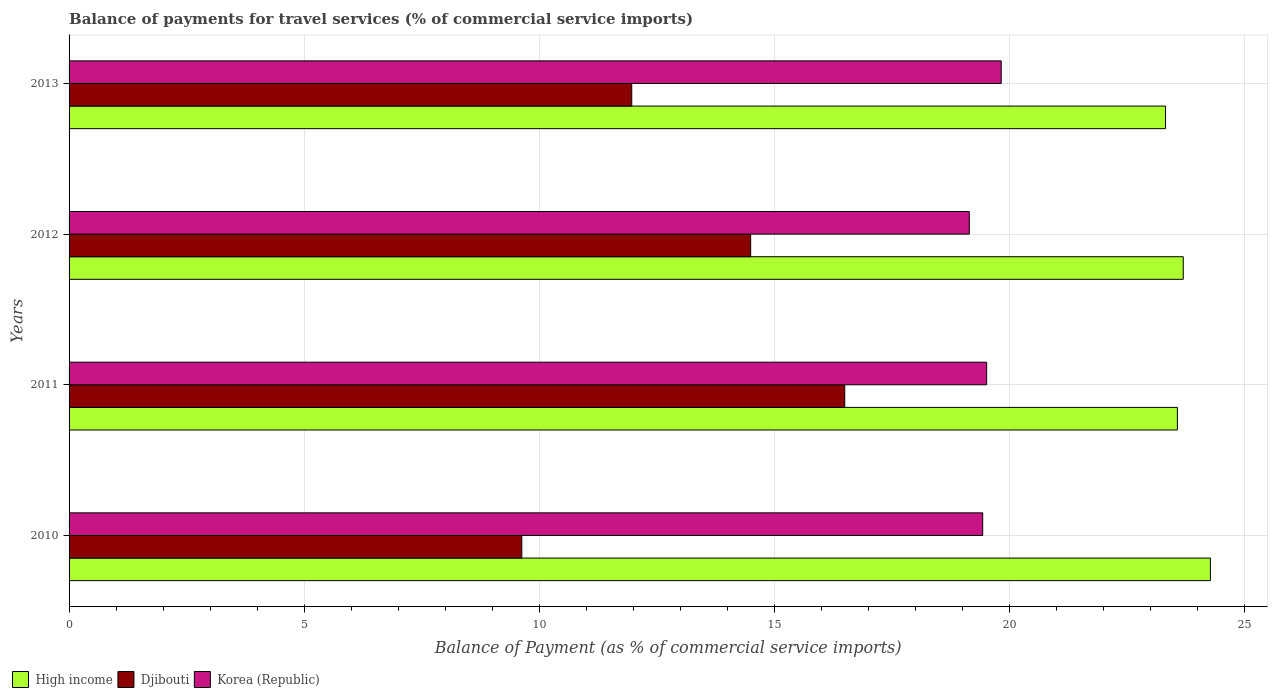How many different coloured bars are there?
Provide a short and direct response. 3. How many bars are there on the 3rd tick from the top?
Provide a succinct answer. 3. What is the label of the 2nd group of bars from the top?
Offer a very short reply. 2012. In how many cases, is the number of bars for a given year not equal to the number of legend labels?
Offer a very short reply. 0. What is the balance of payments for travel services in Djibouti in 2010?
Ensure brevity in your answer.  9.63. Across all years, what is the maximum balance of payments for travel services in Djibouti?
Offer a terse response. 16.5. Across all years, what is the minimum balance of payments for travel services in Djibouti?
Provide a succinct answer. 9.63. In which year was the balance of payments for travel services in Djibouti maximum?
Give a very brief answer. 2011. What is the total balance of payments for travel services in Djibouti in the graph?
Your response must be concise. 52.61. What is the difference between the balance of payments for travel services in Djibouti in 2010 and that in 2012?
Your answer should be very brief. -4.87. What is the difference between the balance of payments for travel services in Djibouti in 2011 and the balance of payments for travel services in High income in 2012?
Give a very brief answer. -7.2. What is the average balance of payments for travel services in Djibouti per year?
Ensure brevity in your answer.  13.15. In the year 2011, what is the difference between the balance of payments for travel services in Djibouti and balance of payments for travel services in High income?
Make the answer very short. -7.08. In how many years, is the balance of payments for travel services in Djibouti greater than 3 %?
Ensure brevity in your answer.  4. What is the ratio of the balance of payments for travel services in Djibouti in 2010 to that in 2011?
Offer a very short reply. 0.58. What is the difference between the highest and the second highest balance of payments for travel services in High income?
Your answer should be compact. 0.58. What is the difference between the highest and the lowest balance of payments for travel services in High income?
Your response must be concise. 0.95. In how many years, is the balance of payments for travel services in High income greater than the average balance of payments for travel services in High income taken over all years?
Offer a very short reply. 1. What does the 3rd bar from the bottom in 2013 represents?
Provide a short and direct response. Korea (Republic). How many bars are there?
Your response must be concise. 12. Are the values on the major ticks of X-axis written in scientific E-notation?
Your answer should be very brief. No. Does the graph contain grids?
Your answer should be very brief. Yes. Where does the legend appear in the graph?
Offer a very short reply. Bottom left. How many legend labels are there?
Offer a terse response. 3. How are the legend labels stacked?
Provide a succinct answer. Horizontal. What is the title of the graph?
Your answer should be compact. Balance of payments for travel services (% of commercial service imports). Does "Sao Tome and Principe" appear as one of the legend labels in the graph?
Give a very brief answer. No. What is the label or title of the X-axis?
Offer a very short reply. Balance of Payment (as % of commercial service imports). What is the label or title of the Y-axis?
Keep it short and to the point. Years. What is the Balance of Payment (as % of commercial service imports) in High income in 2010?
Your response must be concise. 24.28. What is the Balance of Payment (as % of commercial service imports) of Djibouti in 2010?
Give a very brief answer. 9.63. What is the Balance of Payment (as % of commercial service imports) in Korea (Republic) in 2010?
Provide a succinct answer. 19.44. What is the Balance of Payment (as % of commercial service imports) of High income in 2011?
Your answer should be compact. 23.58. What is the Balance of Payment (as % of commercial service imports) in Djibouti in 2011?
Offer a very short reply. 16.5. What is the Balance of Payment (as % of commercial service imports) in Korea (Republic) in 2011?
Keep it short and to the point. 19.52. What is the Balance of Payment (as % of commercial service imports) of High income in 2012?
Offer a terse response. 23.7. What is the Balance of Payment (as % of commercial service imports) of Djibouti in 2012?
Your answer should be compact. 14.5. What is the Balance of Payment (as % of commercial service imports) of Korea (Republic) in 2012?
Provide a short and direct response. 19.15. What is the Balance of Payment (as % of commercial service imports) in High income in 2013?
Keep it short and to the point. 23.33. What is the Balance of Payment (as % of commercial service imports) in Djibouti in 2013?
Ensure brevity in your answer.  11.97. What is the Balance of Payment (as % of commercial service imports) in Korea (Republic) in 2013?
Ensure brevity in your answer.  19.83. Across all years, what is the maximum Balance of Payment (as % of commercial service imports) of High income?
Make the answer very short. 24.28. Across all years, what is the maximum Balance of Payment (as % of commercial service imports) in Djibouti?
Give a very brief answer. 16.5. Across all years, what is the maximum Balance of Payment (as % of commercial service imports) in Korea (Republic)?
Make the answer very short. 19.83. Across all years, what is the minimum Balance of Payment (as % of commercial service imports) in High income?
Your response must be concise. 23.33. Across all years, what is the minimum Balance of Payment (as % of commercial service imports) in Djibouti?
Your answer should be very brief. 9.63. Across all years, what is the minimum Balance of Payment (as % of commercial service imports) of Korea (Republic)?
Provide a short and direct response. 19.15. What is the total Balance of Payment (as % of commercial service imports) of High income in the graph?
Provide a succinct answer. 94.89. What is the total Balance of Payment (as % of commercial service imports) of Djibouti in the graph?
Make the answer very short. 52.61. What is the total Balance of Payment (as % of commercial service imports) of Korea (Republic) in the graph?
Keep it short and to the point. 77.94. What is the difference between the Balance of Payment (as % of commercial service imports) in High income in 2010 and that in 2011?
Give a very brief answer. 0.7. What is the difference between the Balance of Payment (as % of commercial service imports) of Djibouti in 2010 and that in 2011?
Provide a short and direct response. -6.87. What is the difference between the Balance of Payment (as % of commercial service imports) of Korea (Republic) in 2010 and that in 2011?
Keep it short and to the point. -0.08. What is the difference between the Balance of Payment (as % of commercial service imports) of High income in 2010 and that in 2012?
Your answer should be compact. 0.58. What is the difference between the Balance of Payment (as % of commercial service imports) of Djibouti in 2010 and that in 2012?
Provide a short and direct response. -4.87. What is the difference between the Balance of Payment (as % of commercial service imports) of Korea (Republic) in 2010 and that in 2012?
Provide a short and direct response. 0.28. What is the difference between the Balance of Payment (as % of commercial service imports) of High income in 2010 and that in 2013?
Your response must be concise. 0.95. What is the difference between the Balance of Payment (as % of commercial service imports) in Djibouti in 2010 and that in 2013?
Keep it short and to the point. -2.34. What is the difference between the Balance of Payment (as % of commercial service imports) in Korea (Republic) in 2010 and that in 2013?
Offer a very short reply. -0.39. What is the difference between the Balance of Payment (as % of commercial service imports) of High income in 2011 and that in 2012?
Your answer should be very brief. -0.13. What is the difference between the Balance of Payment (as % of commercial service imports) in Djibouti in 2011 and that in 2012?
Provide a succinct answer. 2. What is the difference between the Balance of Payment (as % of commercial service imports) in Korea (Republic) in 2011 and that in 2012?
Keep it short and to the point. 0.37. What is the difference between the Balance of Payment (as % of commercial service imports) in High income in 2011 and that in 2013?
Your response must be concise. 0.25. What is the difference between the Balance of Payment (as % of commercial service imports) of Djibouti in 2011 and that in 2013?
Make the answer very short. 4.53. What is the difference between the Balance of Payment (as % of commercial service imports) of Korea (Republic) in 2011 and that in 2013?
Give a very brief answer. -0.31. What is the difference between the Balance of Payment (as % of commercial service imports) of High income in 2012 and that in 2013?
Provide a succinct answer. 0.38. What is the difference between the Balance of Payment (as % of commercial service imports) of Djibouti in 2012 and that in 2013?
Provide a short and direct response. 2.53. What is the difference between the Balance of Payment (as % of commercial service imports) of Korea (Republic) in 2012 and that in 2013?
Your response must be concise. -0.68. What is the difference between the Balance of Payment (as % of commercial service imports) in High income in 2010 and the Balance of Payment (as % of commercial service imports) in Djibouti in 2011?
Give a very brief answer. 7.78. What is the difference between the Balance of Payment (as % of commercial service imports) in High income in 2010 and the Balance of Payment (as % of commercial service imports) in Korea (Republic) in 2011?
Provide a succinct answer. 4.76. What is the difference between the Balance of Payment (as % of commercial service imports) in Djibouti in 2010 and the Balance of Payment (as % of commercial service imports) in Korea (Republic) in 2011?
Make the answer very short. -9.89. What is the difference between the Balance of Payment (as % of commercial service imports) in High income in 2010 and the Balance of Payment (as % of commercial service imports) in Djibouti in 2012?
Make the answer very short. 9.78. What is the difference between the Balance of Payment (as % of commercial service imports) in High income in 2010 and the Balance of Payment (as % of commercial service imports) in Korea (Republic) in 2012?
Make the answer very short. 5.13. What is the difference between the Balance of Payment (as % of commercial service imports) of Djibouti in 2010 and the Balance of Payment (as % of commercial service imports) of Korea (Republic) in 2012?
Your response must be concise. -9.52. What is the difference between the Balance of Payment (as % of commercial service imports) in High income in 2010 and the Balance of Payment (as % of commercial service imports) in Djibouti in 2013?
Your response must be concise. 12.31. What is the difference between the Balance of Payment (as % of commercial service imports) in High income in 2010 and the Balance of Payment (as % of commercial service imports) in Korea (Republic) in 2013?
Keep it short and to the point. 4.45. What is the difference between the Balance of Payment (as % of commercial service imports) in Djibouti in 2010 and the Balance of Payment (as % of commercial service imports) in Korea (Republic) in 2013?
Keep it short and to the point. -10.2. What is the difference between the Balance of Payment (as % of commercial service imports) in High income in 2011 and the Balance of Payment (as % of commercial service imports) in Djibouti in 2012?
Offer a terse response. 9.08. What is the difference between the Balance of Payment (as % of commercial service imports) of High income in 2011 and the Balance of Payment (as % of commercial service imports) of Korea (Republic) in 2012?
Provide a succinct answer. 4.43. What is the difference between the Balance of Payment (as % of commercial service imports) in Djibouti in 2011 and the Balance of Payment (as % of commercial service imports) in Korea (Republic) in 2012?
Your answer should be compact. -2.65. What is the difference between the Balance of Payment (as % of commercial service imports) in High income in 2011 and the Balance of Payment (as % of commercial service imports) in Djibouti in 2013?
Make the answer very short. 11.61. What is the difference between the Balance of Payment (as % of commercial service imports) in High income in 2011 and the Balance of Payment (as % of commercial service imports) in Korea (Republic) in 2013?
Offer a terse response. 3.75. What is the difference between the Balance of Payment (as % of commercial service imports) in Djibouti in 2011 and the Balance of Payment (as % of commercial service imports) in Korea (Republic) in 2013?
Your response must be concise. -3.33. What is the difference between the Balance of Payment (as % of commercial service imports) of High income in 2012 and the Balance of Payment (as % of commercial service imports) of Djibouti in 2013?
Make the answer very short. 11.73. What is the difference between the Balance of Payment (as % of commercial service imports) in High income in 2012 and the Balance of Payment (as % of commercial service imports) in Korea (Republic) in 2013?
Provide a short and direct response. 3.87. What is the difference between the Balance of Payment (as % of commercial service imports) in Djibouti in 2012 and the Balance of Payment (as % of commercial service imports) in Korea (Republic) in 2013?
Keep it short and to the point. -5.33. What is the average Balance of Payment (as % of commercial service imports) of High income per year?
Give a very brief answer. 23.72. What is the average Balance of Payment (as % of commercial service imports) of Djibouti per year?
Provide a succinct answer. 13.15. What is the average Balance of Payment (as % of commercial service imports) in Korea (Republic) per year?
Give a very brief answer. 19.49. In the year 2010, what is the difference between the Balance of Payment (as % of commercial service imports) in High income and Balance of Payment (as % of commercial service imports) in Djibouti?
Offer a terse response. 14.65. In the year 2010, what is the difference between the Balance of Payment (as % of commercial service imports) of High income and Balance of Payment (as % of commercial service imports) of Korea (Republic)?
Provide a short and direct response. 4.85. In the year 2010, what is the difference between the Balance of Payment (as % of commercial service imports) in Djibouti and Balance of Payment (as % of commercial service imports) in Korea (Republic)?
Your answer should be compact. -9.81. In the year 2011, what is the difference between the Balance of Payment (as % of commercial service imports) in High income and Balance of Payment (as % of commercial service imports) in Djibouti?
Provide a short and direct response. 7.08. In the year 2011, what is the difference between the Balance of Payment (as % of commercial service imports) of High income and Balance of Payment (as % of commercial service imports) of Korea (Republic)?
Your response must be concise. 4.06. In the year 2011, what is the difference between the Balance of Payment (as % of commercial service imports) in Djibouti and Balance of Payment (as % of commercial service imports) in Korea (Republic)?
Make the answer very short. -3.02. In the year 2012, what is the difference between the Balance of Payment (as % of commercial service imports) in High income and Balance of Payment (as % of commercial service imports) in Djibouti?
Ensure brevity in your answer.  9.2. In the year 2012, what is the difference between the Balance of Payment (as % of commercial service imports) in High income and Balance of Payment (as % of commercial service imports) in Korea (Republic)?
Offer a very short reply. 4.55. In the year 2012, what is the difference between the Balance of Payment (as % of commercial service imports) in Djibouti and Balance of Payment (as % of commercial service imports) in Korea (Republic)?
Provide a short and direct response. -4.65. In the year 2013, what is the difference between the Balance of Payment (as % of commercial service imports) in High income and Balance of Payment (as % of commercial service imports) in Djibouti?
Provide a short and direct response. 11.36. In the year 2013, what is the difference between the Balance of Payment (as % of commercial service imports) in High income and Balance of Payment (as % of commercial service imports) in Korea (Republic)?
Offer a very short reply. 3.5. In the year 2013, what is the difference between the Balance of Payment (as % of commercial service imports) of Djibouti and Balance of Payment (as % of commercial service imports) of Korea (Republic)?
Offer a terse response. -7.86. What is the ratio of the Balance of Payment (as % of commercial service imports) of High income in 2010 to that in 2011?
Offer a terse response. 1.03. What is the ratio of the Balance of Payment (as % of commercial service imports) in Djibouti in 2010 to that in 2011?
Provide a succinct answer. 0.58. What is the ratio of the Balance of Payment (as % of commercial service imports) of High income in 2010 to that in 2012?
Give a very brief answer. 1.02. What is the ratio of the Balance of Payment (as % of commercial service imports) in Djibouti in 2010 to that in 2012?
Keep it short and to the point. 0.66. What is the ratio of the Balance of Payment (as % of commercial service imports) in Korea (Republic) in 2010 to that in 2012?
Keep it short and to the point. 1.01. What is the ratio of the Balance of Payment (as % of commercial service imports) of High income in 2010 to that in 2013?
Provide a short and direct response. 1.04. What is the ratio of the Balance of Payment (as % of commercial service imports) in Djibouti in 2010 to that in 2013?
Your answer should be compact. 0.8. What is the ratio of the Balance of Payment (as % of commercial service imports) of Korea (Republic) in 2010 to that in 2013?
Provide a succinct answer. 0.98. What is the ratio of the Balance of Payment (as % of commercial service imports) in Djibouti in 2011 to that in 2012?
Your answer should be compact. 1.14. What is the ratio of the Balance of Payment (as % of commercial service imports) in Korea (Republic) in 2011 to that in 2012?
Provide a short and direct response. 1.02. What is the ratio of the Balance of Payment (as % of commercial service imports) of High income in 2011 to that in 2013?
Your answer should be compact. 1.01. What is the ratio of the Balance of Payment (as % of commercial service imports) of Djibouti in 2011 to that in 2013?
Your response must be concise. 1.38. What is the ratio of the Balance of Payment (as % of commercial service imports) of Korea (Republic) in 2011 to that in 2013?
Ensure brevity in your answer.  0.98. What is the ratio of the Balance of Payment (as % of commercial service imports) of High income in 2012 to that in 2013?
Keep it short and to the point. 1.02. What is the ratio of the Balance of Payment (as % of commercial service imports) in Djibouti in 2012 to that in 2013?
Make the answer very short. 1.21. What is the ratio of the Balance of Payment (as % of commercial service imports) in Korea (Republic) in 2012 to that in 2013?
Your answer should be very brief. 0.97. What is the difference between the highest and the second highest Balance of Payment (as % of commercial service imports) of High income?
Your answer should be compact. 0.58. What is the difference between the highest and the second highest Balance of Payment (as % of commercial service imports) of Djibouti?
Keep it short and to the point. 2. What is the difference between the highest and the second highest Balance of Payment (as % of commercial service imports) of Korea (Republic)?
Provide a short and direct response. 0.31. What is the difference between the highest and the lowest Balance of Payment (as % of commercial service imports) of High income?
Ensure brevity in your answer.  0.95. What is the difference between the highest and the lowest Balance of Payment (as % of commercial service imports) in Djibouti?
Your answer should be very brief. 6.87. What is the difference between the highest and the lowest Balance of Payment (as % of commercial service imports) of Korea (Republic)?
Your response must be concise. 0.68. 